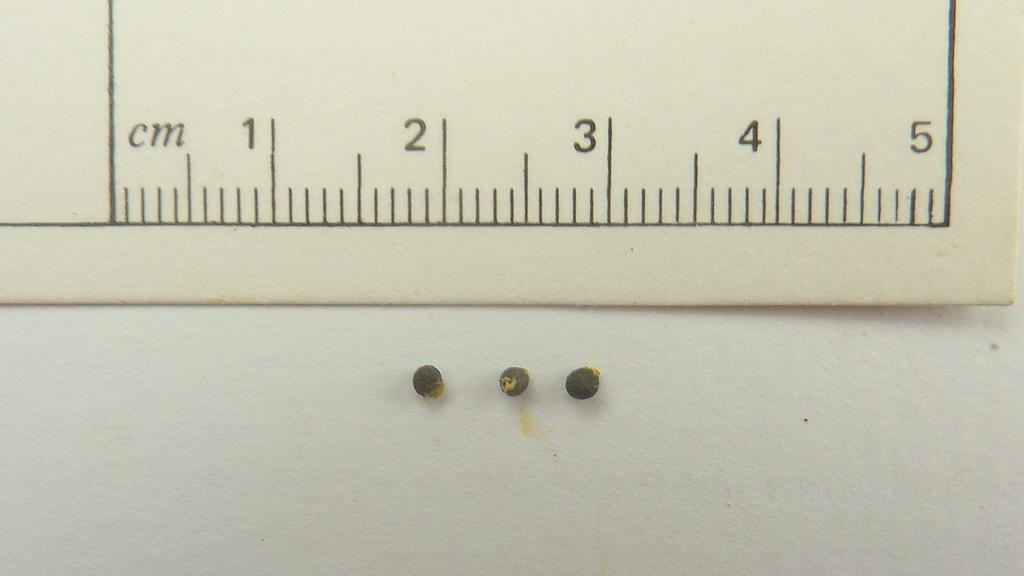<image>
Present a compact description of the photo's key features. Three small beads under a white ruler that says CM on it. 